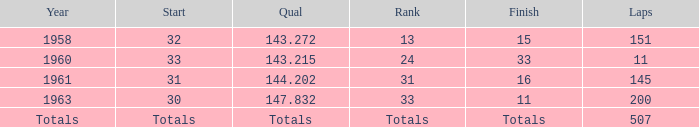The qual of totals took place during what year? Totals. 